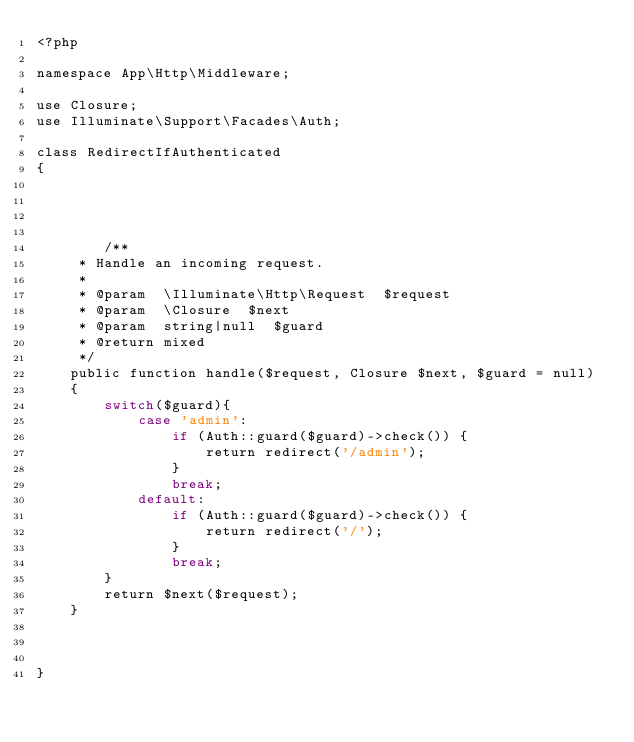Convert code to text. <code><loc_0><loc_0><loc_500><loc_500><_PHP_><?php

namespace App\Http\Middleware;

use Closure;
use Illuminate\Support\Facades\Auth;

class RedirectIfAuthenticated
{
    



        /**
     * Handle an incoming request.
     *
     * @param  \Illuminate\Http\Request  $request
     * @param  \Closure  $next
     * @param  string|null  $guard
     * @return mixed
     */
    public function handle($request, Closure $next, $guard = null)
    {
        switch($guard){
            case 'admin':
                if (Auth::guard($guard)->check()) {
                    return redirect('/admin');
                }
                break;
            default:
                if (Auth::guard($guard)->check()) {
                    return redirect('/');
                }
                break;
        }
        return $next($request);
    }

    
   
}

</code> 